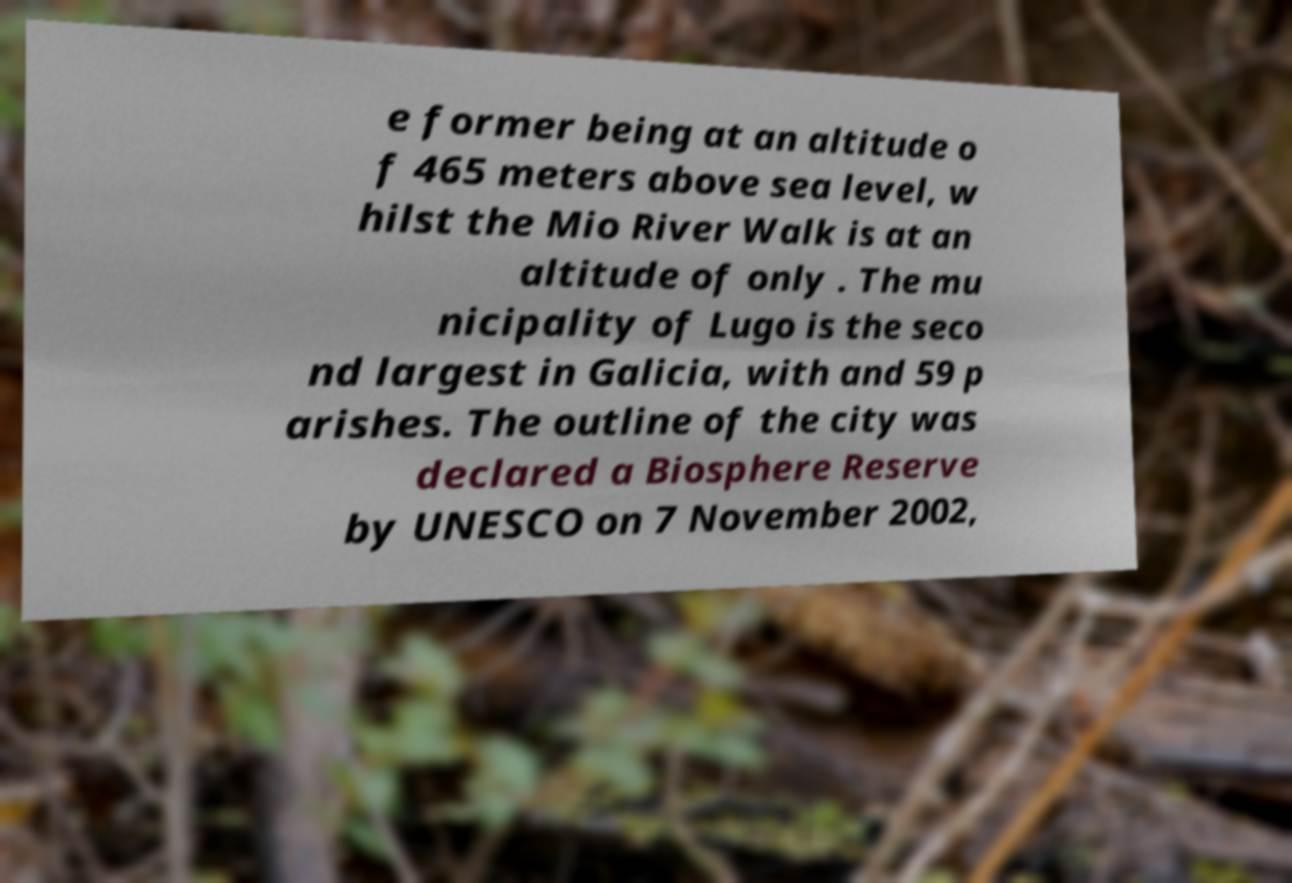What messages or text are displayed in this image? I need them in a readable, typed format. e former being at an altitude o f 465 meters above sea level, w hilst the Mio River Walk is at an altitude of only . The mu nicipality of Lugo is the seco nd largest in Galicia, with and 59 p arishes. The outline of the city was declared a Biosphere Reserve by UNESCO on 7 November 2002, 